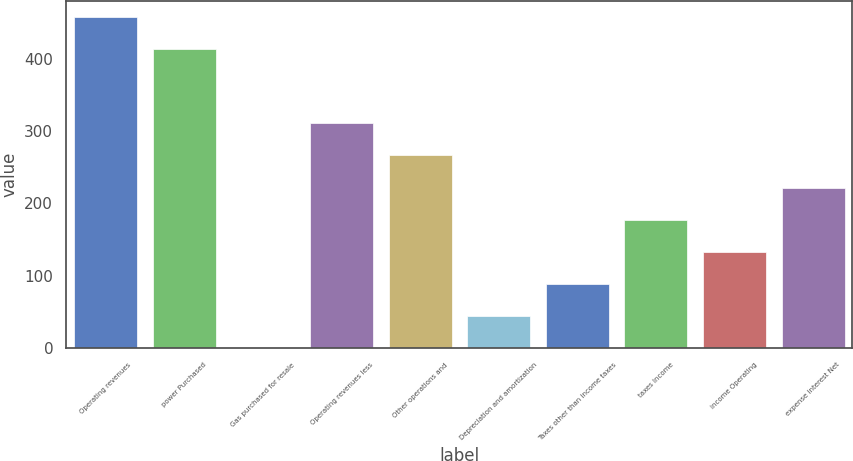Convert chart to OTSL. <chart><loc_0><loc_0><loc_500><loc_500><bar_chart><fcel>Operating revenues<fcel>power Purchased<fcel>Gas purchased for resale<fcel>Operating revenues less<fcel>Other operations and<fcel>Depreciation and amortization<fcel>Taxes other than income taxes<fcel>taxes Income<fcel>income Operating<fcel>expense interest Net<nl><fcel>457.2<fcel>413<fcel>1<fcel>310.4<fcel>266.2<fcel>45.2<fcel>89.4<fcel>177.8<fcel>133.6<fcel>222<nl></chart> 